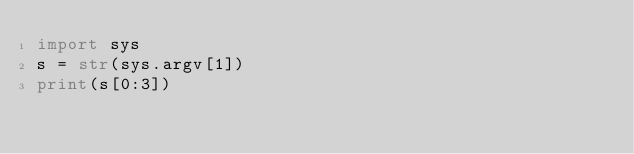Convert code to text. <code><loc_0><loc_0><loc_500><loc_500><_Python_>import sys
s = str(sys.argv[1])
print(s[0:3])</code> 